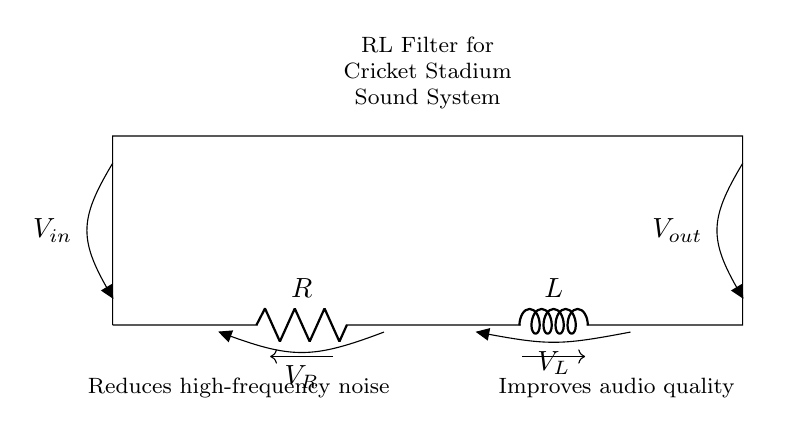What components are present in this circuit? The circuit diagram clearly shows a resistor (R) and an inductor (L) connected in series. The labels on each component confirm their identity.
Answer: resistor and inductor What is the role of the resistor in this RL filter? The resistor is used to limit the current flowing through the circuit, which helps in reducing high-frequency noise. Its placement in the circuit indicates its function in audio applications.
Answer: limit current What does Vout represent in the circuit? Vout is the voltage output taken from the circuit after the inductor. It represents the filtered audio signal that has reduced noise. This can be understood from its placement after the R and L.
Answer: filtered audio signal How does the inductor affect the audio signal? The inductor blocks high-frequency signals while allowing lower-frequency signals to pass through. This characteristic is critical in filters designed to improve audio quality by reducing unwanted noise.
Answer: blocks high-frequency signals What type of filter is represented in this circuit? This circuit is a low-pass filter, which allows low-frequency signals to pass while attenuating high-frequency components. The arrangement of the resistor and inductor confirms this functionality.
Answer: low-pass filter What does the voltage drop across the resistor indicate? The voltage drop across the resistor indicates the amount of voltage being used to overcome the resistance and provides insight into the power dissipation in the circuit. This can be derived from Ohm's law applied in this RL configuration.
Answer: power dissipation What is the main purpose of this RL filter in a cricket stadium sound system? The main purpose of this RL filter is to enhance audio quality by reducing high-frequency noise that can be distracting in a live environment. This is stated in the diagram notes.
Answer: improve audio quality 